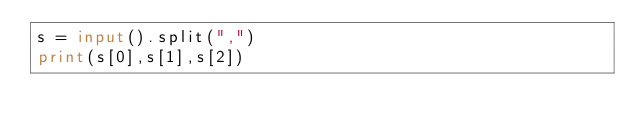Convert code to text. <code><loc_0><loc_0><loc_500><loc_500><_Python_>s = input().split(",")
print(s[0],s[1],s[2])</code> 